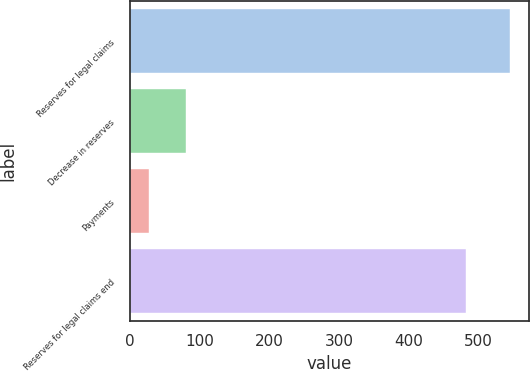Convert chart. <chart><loc_0><loc_0><loc_500><loc_500><bar_chart><fcel>Reserves for legal claims<fcel>Decrease in reserves<fcel>Payments<fcel>Reserves for legal claims end<nl><fcel>544.9<fcel>79.96<fcel>28.3<fcel>482<nl></chart> 